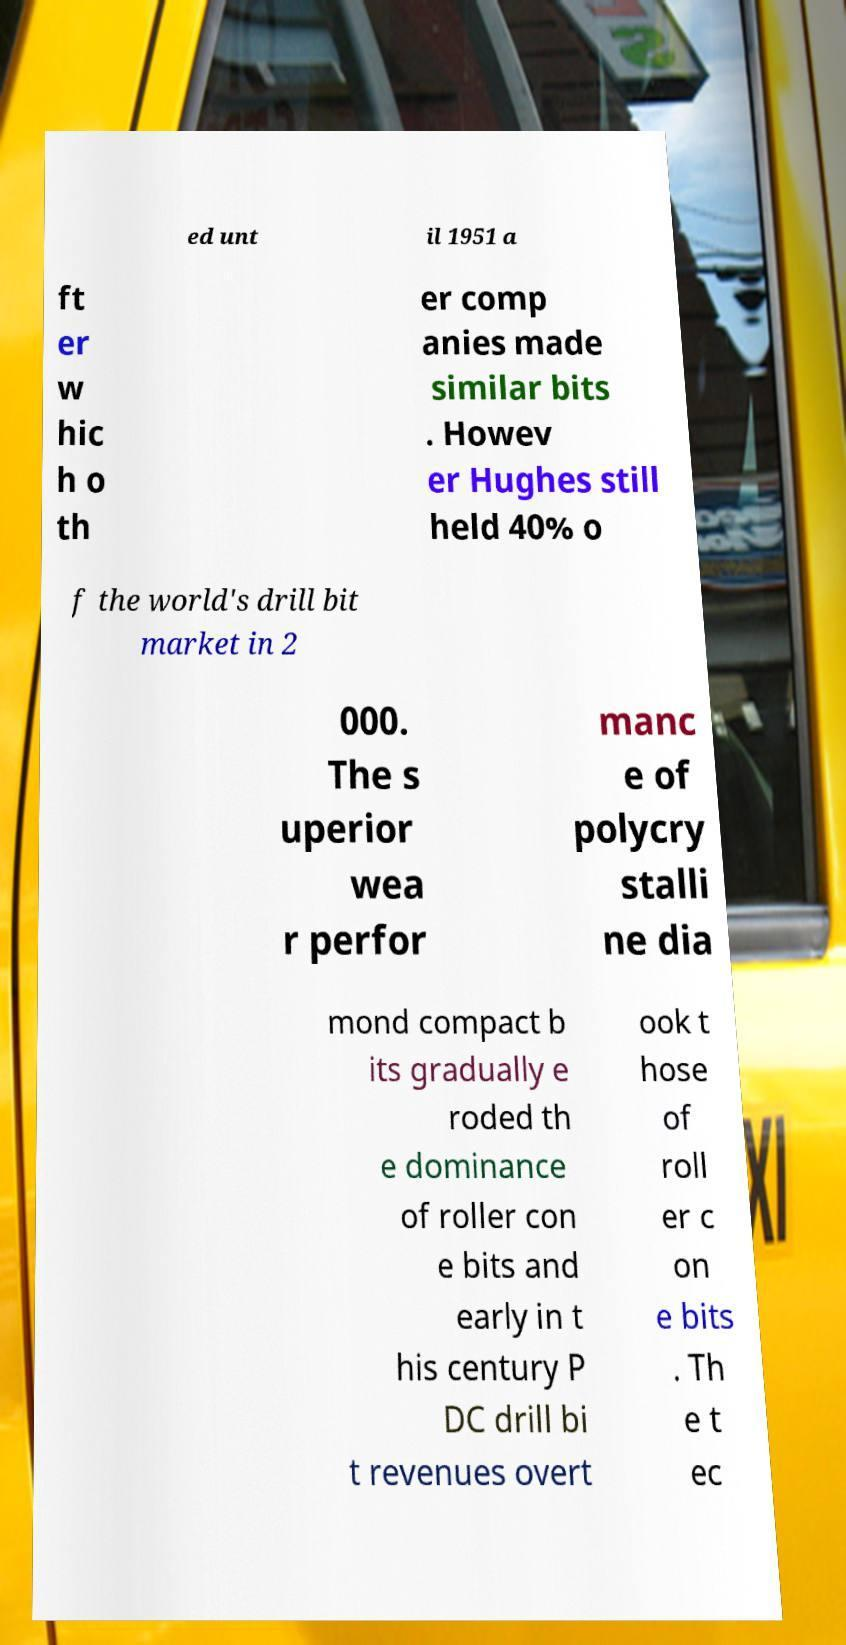Could you assist in decoding the text presented in this image and type it out clearly? ed unt il 1951 a ft er w hic h o th er comp anies made similar bits . Howev er Hughes still held 40% o f the world's drill bit market in 2 000. The s uperior wea r perfor manc e of polycry stalli ne dia mond compact b its gradually e roded th e dominance of roller con e bits and early in t his century P DC drill bi t revenues overt ook t hose of roll er c on e bits . Th e t ec 